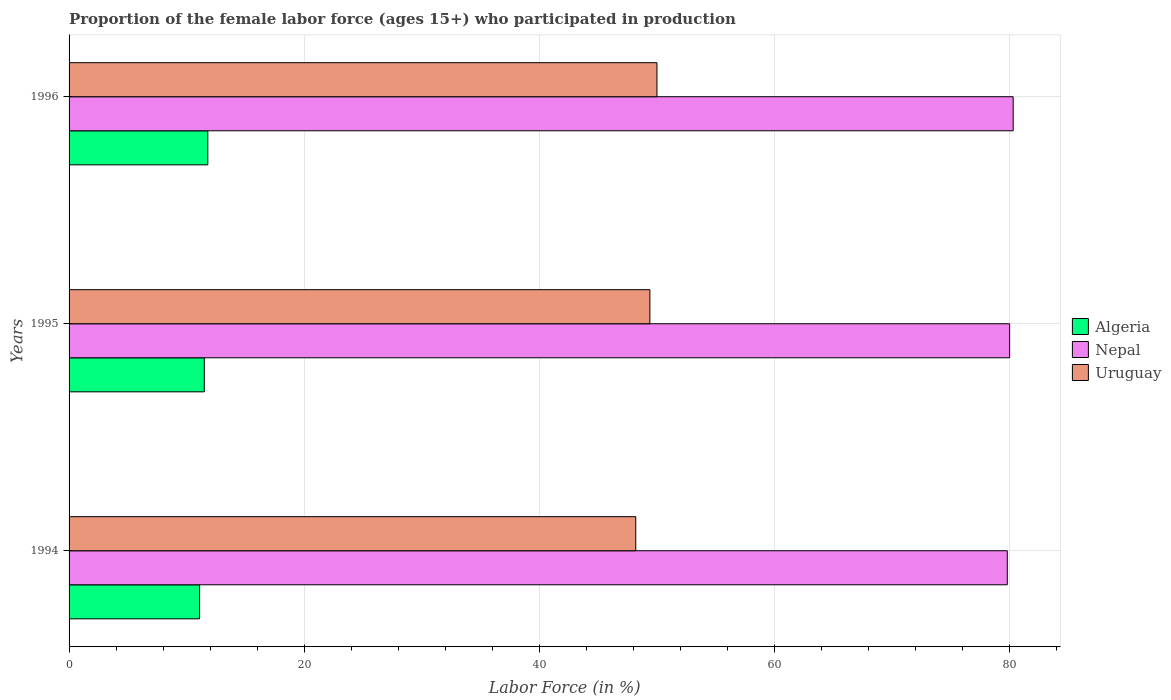How many different coloured bars are there?
Keep it short and to the point. 3. How many groups of bars are there?
Keep it short and to the point. 3. How many bars are there on the 3rd tick from the bottom?
Offer a very short reply. 3. What is the proportion of the female labor force who participated in production in Uruguay in 1994?
Ensure brevity in your answer.  48.2. Across all years, what is the maximum proportion of the female labor force who participated in production in Nepal?
Offer a terse response. 80.3. Across all years, what is the minimum proportion of the female labor force who participated in production in Algeria?
Your answer should be compact. 11.1. What is the total proportion of the female labor force who participated in production in Nepal in the graph?
Make the answer very short. 240.1. What is the difference between the proportion of the female labor force who participated in production in Algeria in 1995 and that in 1996?
Offer a very short reply. -0.3. What is the difference between the proportion of the female labor force who participated in production in Nepal in 1994 and the proportion of the female labor force who participated in production in Algeria in 1996?
Your response must be concise. 68. What is the average proportion of the female labor force who participated in production in Algeria per year?
Your answer should be compact. 11.47. In the year 1996, what is the difference between the proportion of the female labor force who participated in production in Nepal and proportion of the female labor force who participated in production in Algeria?
Keep it short and to the point. 68.5. What is the ratio of the proportion of the female labor force who participated in production in Uruguay in 1994 to that in 1996?
Your answer should be very brief. 0.96. Is the proportion of the female labor force who participated in production in Algeria in 1994 less than that in 1995?
Offer a terse response. Yes. Is the difference between the proportion of the female labor force who participated in production in Nepal in 1994 and 1996 greater than the difference between the proportion of the female labor force who participated in production in Algeria in 1994 and 1996?
Your response must be concise. Yes. What is the difference between the highest and the second highest proportion of the female labor force who participated in production in Algeria?
Make the answer very short. 0.3. What is the difference between the highest and the lowest proportion of the female labor force who participated in production in Algeria?
Your answer should be very brief. 0.7. What does the 2nd bar from the top in 1996 represents?
Your answer should be compact. Nepal. What does the 2nd bar from the bottom in 1996 represents?
Your answer should be compact. Nepal. How many bars are there?
Your answer should be very brief. 9. Are all the bars in the graph horizontal?
Offer a terse response. Yes. How many years are there in the graph?
Your answer should be very brief. 3. What is the difference between two consecutive major ticks on the X-axis?
Ensure brevity in your answer.  20. Does the graph contain any zero values?
Offer a terse response. No. What is the title of the graph?
Provide a short and direct response. Proportion of the female labor force (ages 15+) who participated in production. What is the Labor Force (in %) in Algeria in 1994?
Offer a very short reply. 11.1. What is the Labor Force (in %) of Nepal in 1994?
Your answer should be compact. 79.8. What is the Labor Force (in %) in Uruguay in 1994?
Give a very brief answer. 48.2. What is the Labor Force (in %) in Nepal in 1995?
Your response must be concise. 80. What is the Labor Force (in %) of Uruguay in 1995?
Offer a terse response. 49.4. What is the Labor Force (in %) in Algeria in 1996?
Provide a succinct answer. 11.8. What is the Labor Force (in %) of Nepal in 1996?
Your response must be concise. 80.3. Across all years, what is the maximum Labor Force (in %) in Algeria?
Keep it short and to the point. 11.8. Across all years, what is the maximum Labor Force (in %) of Nepal?
Keep it short and to the point. 80.3. Across all years, what is the minimum Labor Force (in %) of Algeria?
Make the answer very short. 11.1. Across all years, what is the minimum Labor Force (in %) in Nepal?
Ensure brevity in your answer.  79.8. Across all years, what is the minimum Labor Force (in %) of Uruguay?
Offer a very short reply. 48.2. What is the total Labor Force (in %) of Algeria in the graph?
Ensure brevity in your answer.  34.4. What is the total Labor Force (in %) of Nepal in the graph?
Offer a terse response. 240.1. What is the total Labor Force (in %) of Uruguay in the graph?
Give a very brief answer. 147.6. What is the difference between the Labor Force (in %) of Uruguay in 1994 and that in 1995?
Your response must be concise. -1.2. What is the difference between the Labor Force (in %) of Nepal in 1994 and that in 1996?
Give a very brief answer. -0.5. What is the difference between the Labor Force (in %) in Uruguay in 1994 and that in 1996?
Your answer should be very brief. -1.8. What is the difference between the Labor Force (in %) of Algeria in 1995 and that in 1996?
Offer a terse response. -0.3. What is the difference between the Labor Force (in %) of Nepal in 1995 and that in 1996?
Keep it short and to the point. -0.3. What is the difference between the Labor Force (in %) in Uruguay in 1995 and that in 1996?
Make the answer very short. -0.6. What is the difference between the Labor Force (in %) of Algeria in 1994 and the Labor Force (in %) of Nepal in 1995?
Your answer should be very brief. -68.9. What is the difference between the Labor Force (in %) in Algeria in 1994 and the Labor Force (in %) in Uruguay in 1995?
Offer a very short reply. -38.3. What is the difference between the Labor Force (in %) of Nepal in 1994 and the Labor Force (in %) of Uruguay in 1995?
Your answer should be compact. 30.4. What is the difference between the Labor Force (in %) of Algeria in 1994 and the Labor Force (in %) of Nepal in 1996?
Give a very brief answer. -69.2. What is the difference between the Labor Force (in %) in Algeria in 1994 and the Labor Force (in %) in Uruguay in 1996?
Your response must be concise. -38.9. What is the difference between the Labor Force (in %) of Nepal in 1994 and the Labor Force (in %) of Uruguay in 1996?
Provide a short and direct response. 29.8. What is the difference between the Labor Force (in %) of Algeria in 1995 and the Labor Force (in %) of Nepal in 1996?
Keep it short and to the point. -68.8. What is the difference between the Labor Force (in %) in Algeria in 1995 and the Labor Force (in %) in Uruguay in 1996?
Provide a short and direct response. -38.5. What is the average Labor Force (in %) of Algeria per year?
Make the answer very short. 11.47. What is the average Labor Force (in %) in Nepal per year?
Your answer should be compact. 80.03. What is the average Labor Force (in %) of Uruguay per year?
Keep it short and to the point. 49.2. In the year 1994, what is the difference between the Labor Force (in %) of Algeria and Labor Force (in %) of Nepal?
Provide a succinct answer. -68.7. In the year 1994, what is the difference between the Labor Force (in %) of Algeria and Labor Force (in %) of Uruguay?
Give a very brief answer. -37.1. In the year 1994, what is the difference between the Labor Force (in %) in Nepal and Labor Force (in %) in Uruguay?
Offer a terse response. 31.6. In the year 1995, what is the difference between the Labor Force (in %) in Algeria and Labor Force (in %) in Nepal?
Provide a short and direct response. -68.5. In the year 1995, what is the difference between the Labor Force (in %) in Algeria and Labor Force (in %) in Uruguay?
Your answer should be compact. -37.9. In the year 1995, what is the difference between the Labor Force (in %) in Nepal and Labor Force (in %) in Uruguay?
Your answer should be compact. 30.6. In the year 1996, what is the difference between the Labor Force (in %) of Algeria and Labor Force (in %) of Nepal?
Keep it short and to the point. -68.5. In the year 1996, what is the difference between the Labor Force (in %) in Algeria and Labor Force (in %) in Uruguay?
Provide a succinct answer. -38.2. In the year 1996, what is the difference between the Labor Force (in %) of Nepal and Labor Force (in %) of Uruguay?
Provide a short and direct response. 30.3. What is the ratio of the Labor Force (in %) of Algeria in 1994 to that in 1995?
Keep it short and to the point. 0.97. What is the ratio of the Labor Force (in %) in Nepal in 1994 to that in 1995?
Your answer should be very brief. 1. What is the ratio of the Labor Force (in %) in Uruguay in 1994 to that in 1995?
Provide a succinct answer. 0.98. What is the ratio of the Labor Force (in %) of Algeria in 1994 to that in 1996?
Offer a very short reply. 0.94. What is the ratio of the Labor Force (in %) of Algeria in 1995 to that in 1996?
Your answer should be compact. 0.97. What is the ratio of the Labor Force (in %) in Uruguay in 1995 to that in 1996?
Your response must be concise. 0.99. What is the difference between the highest and the second highest Labor Force (in %) in Nepal?
Your answer should be compact. 0.3. 